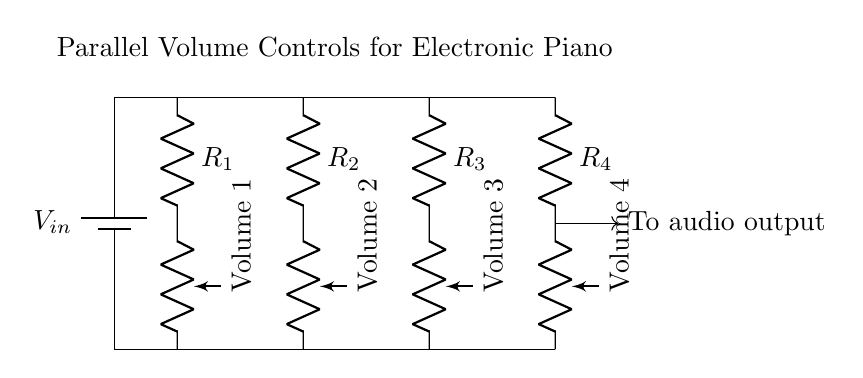What is the type of circuit shown? The circuit is a parallel circuit, where all the components are connected across the same two voltage points. This can be identified by the separate branches that lead from the top row to the bottom row without sharing connections between them.
Answer: Parallel How many volume controls are present in the circuit? There are four volume controls, as indicated by the four separate potentiometers labeled Volume 1, Volume 2, Volume 3, and Volume 4 in the diagram.
Answer: Four What is the function of the resistors in this circuit? The resistors function to limit the current flowing through the individual volume controls, ensuring that the signal is managed correctly for each volume setting. Each resistor is connected in series with its respective potentiometer.
Answer: Current limiting Which component connects to the audio output? The audio output is connected to the point where all volume controls converge at the bottom of the circuit, indicated by the arrow leading towards "To audio output." The connection from the parallel branches comes together before reaching the output.
Answer: Potentiometers What happens to the total resistance in the circuit when more volume controls are added? The total resistance decreases as more volume controls are added in parallel. This is due to the formula for total resistance in parallel circuits, which shows that adding branches provides additional paths for current flow, reducing overall resistance.
Answer: Decreases How would the circuit behave if one volume control is turned to maximum? If one volume control is turned to maximum, it allows the maximum voltage to pass through that branch, allowing full signal flow, while the other volume controls remain unaffected due to the parallel arrangement. Each control operates independently of the others.
Answer: Independent operation 